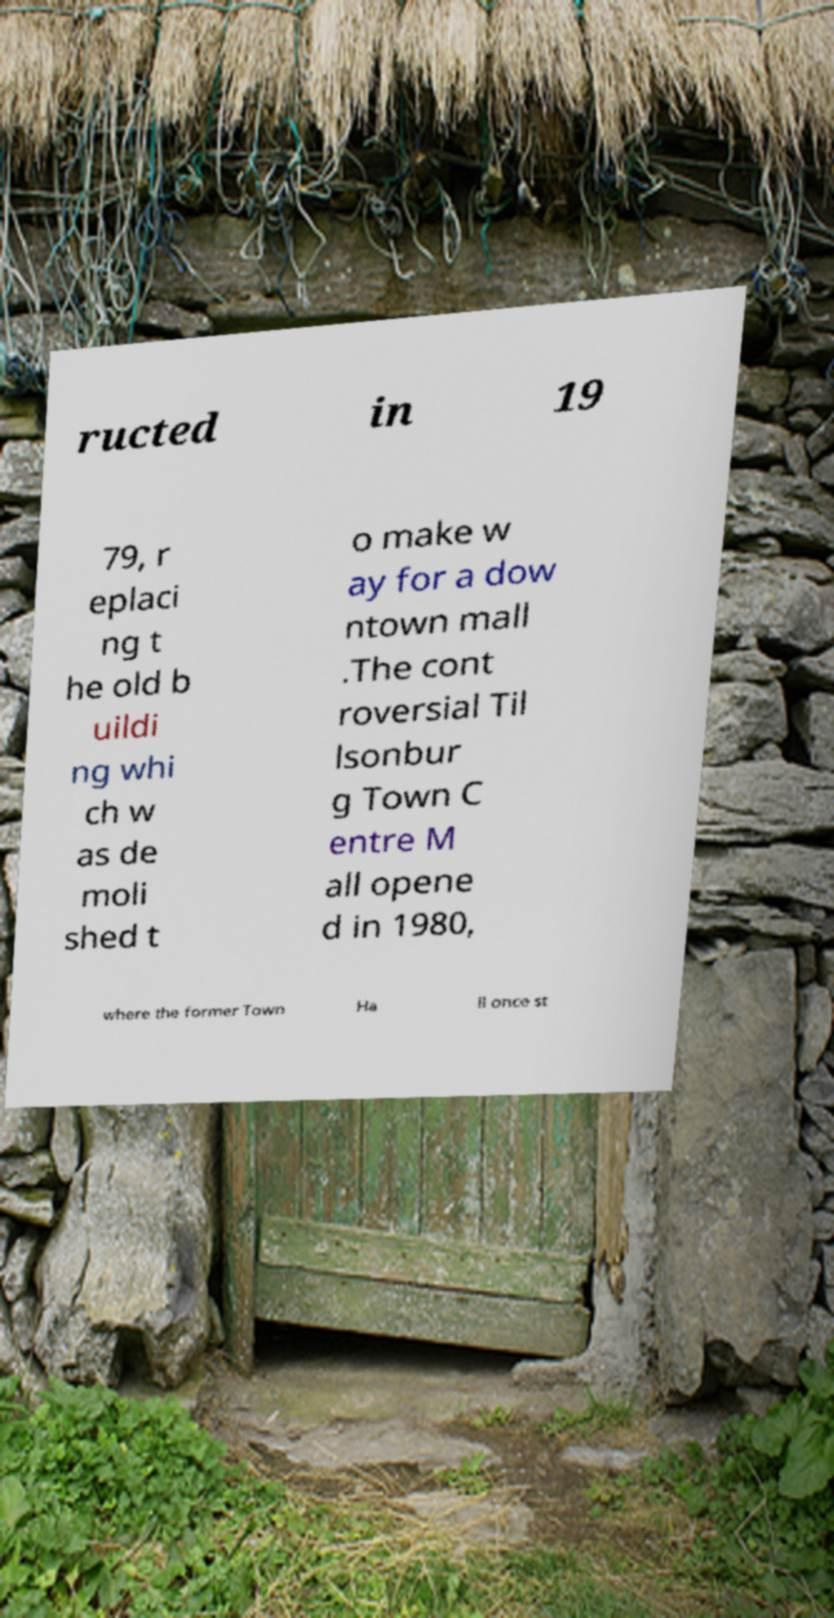Can you accurately transcribe the text from the provided image for me? ructed in 19 79, r eplaci ng t he old b uildi ng whi ch w as de moli shed t o make w ay for a dow ntown mall .The cont roversial Til lsonbur g Town C entre M all opene d in 1980, where the former Town Ha ll once st 